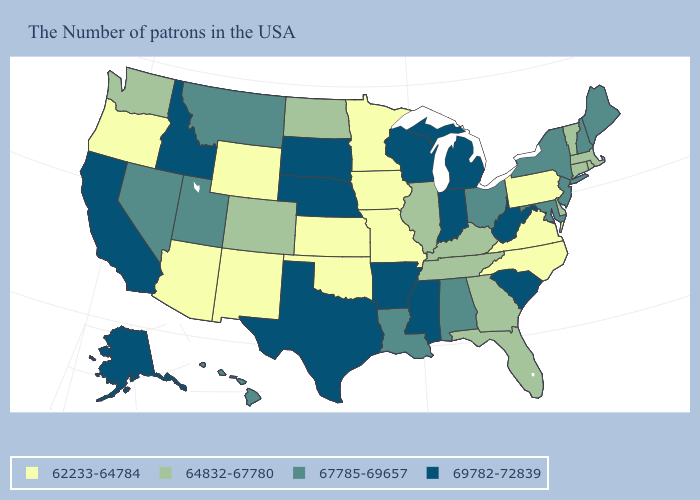Name the states that have a value in the range 64832-67780?
Keep it brief. Massachusetts, Rhode Island, Vermont, Connecticut, Delaware, Florida, Georgia, Kentucky, Tennessee, Illinois, North Dakota, Colorado, Washington. What is the lowest value in the USA?
Write a very short answer. 62233-64784. What is the lowest value in the USA?
Write a very short answer. 62233-64784. What is the value of Nevada?
Answer briefly. 67785-69657. What is the value of Washington?
Write a very short answer. 64832-67780. Name the states that have a value in the range 64832-67780?
Short answer required. Massachusetts, Rhode Island, Vermont, Connecticut, Delaware, Florida, Georgia, Kentucky, Tennessee, Illinois, North Dakota, Colorado, Washington. Among the states that border Ohio , which have the lowest value?
Answer briefly. Pennsylvania. Is the legend a continuous bar?
Keep it brief. No. Among the states that border Florida , which have the lowest value?
Be succinct. Georgia. Name the states that have a value in the range 64832-67780?
Quick response, please. Massachusetts, Rhode Island, Vermont, Connecticut, Delaware, Florida, Georgia, Kentucky, Tennessee, Illinois, North Dakota, Colorado, Washington. Does the map have missing data?
Quick response, please. No. Does Kentucky have the same value as South Dakota?
Write a very short answer. No. Name the states that have a value in the range 64832-67780?
Concise answer only. Massachusetts, Rhode Island, Vermont, Connecticut, Delaware, Florida, Georgia, Kentucky, Tennessee, Illinois, North Dakota, Colorado, Washington. Among the states that border Iowa , does South Dakota have the highest value?
Answer briefly. Yes. Among the states that border Kentucky , which have the highest value?
Concise answer only. West Virginia, Indiana. 